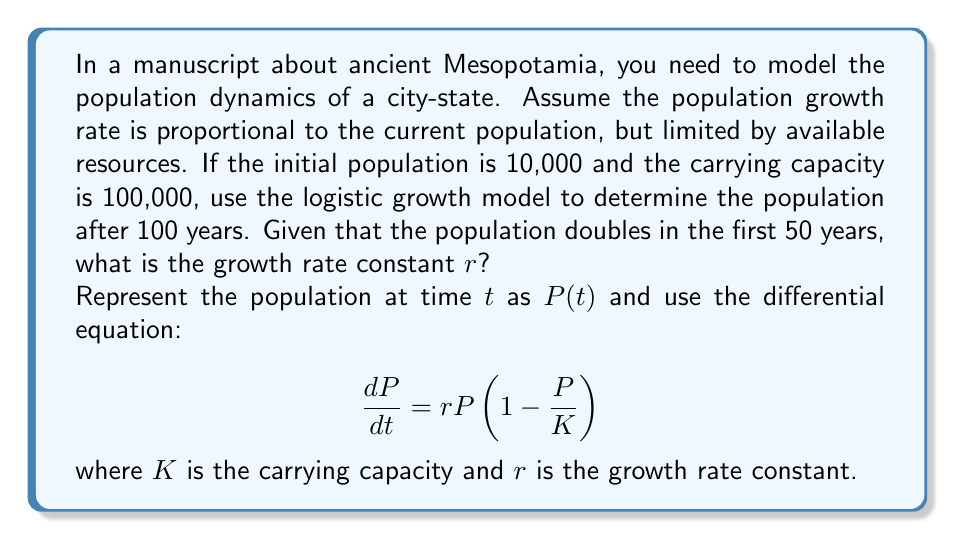Give your solution to this math problem. To solve this problem, we'll follow these steps:

1. Determine the growth rate constant $r$ using the given information.
2. Solve the logistic growth differential equation.
3. Calculate the population after 100 years.

Step 1: Determining $r$

We know that the population doubles in 50 years, so:

$P(50) = 2P(0) = 20,000$

The solution to the logistic growth equation is:

$$P(t) = \frac{K}{1 + (\frac{K}{P(0)} - 1)e^{-rt}}$$

Substituting the known values:

$$20,000 = \frac{100,000}{1 + (\frac{100,000}{10,000} - 1)e^{-50r}}$$

Simplifying:

$$\frac{1}{5} = \frac{1}{1 + 9e^{-50r}}$$

Solving for $r$:

$$9e^{-50r} = 4$$
$$e^{-50r} = \frac{4}{9}$$
$$-50r = \ln(\frac{4}{9})$$
$$r = -\frac{1}{50}\ln(\frac{4}{9}) \approx 0.0161$$

Step 2: Solving the logistic growth equation

Now that we have $r$, we can use the general solution:

$$P(t) = \frac{100,000}{1 + 9e^{-0.0161t}}$$

Step 3: Calculating the population after 100 years

Substitute $t = 100$ into the equation:

$$P(100) = \frac{100,000}{1 + 9e^{-0.0161(100)}}$$

$$P(100) = \frac{100,000}{1 + 9e^{-1.61}} \approx 63,212$$
Answer: The population of the ancient Mesopotamian city-state after 100 years is approximately 63,212 people. 